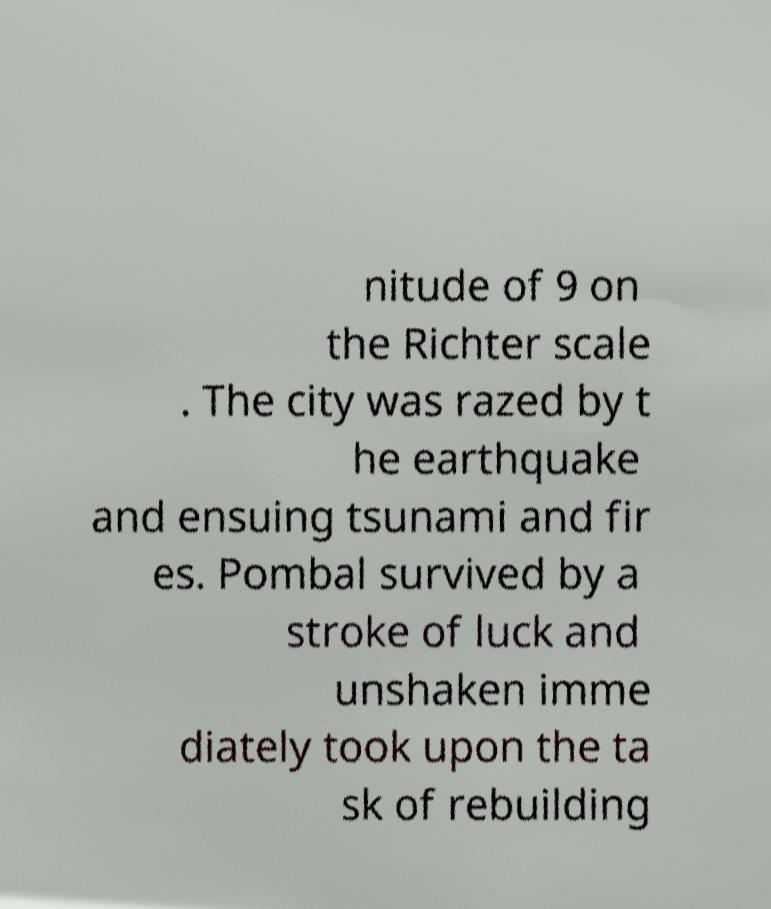Could you assist in decoding the text presented in this image and type it out clearly? nitude of 9 on the Richter scale . The city was razed by t he earthquake and ensuing tsunami and fir es. Pombal survived by a stroke of luck and unshaken imme diately took upon the ta sk of rebuilding 